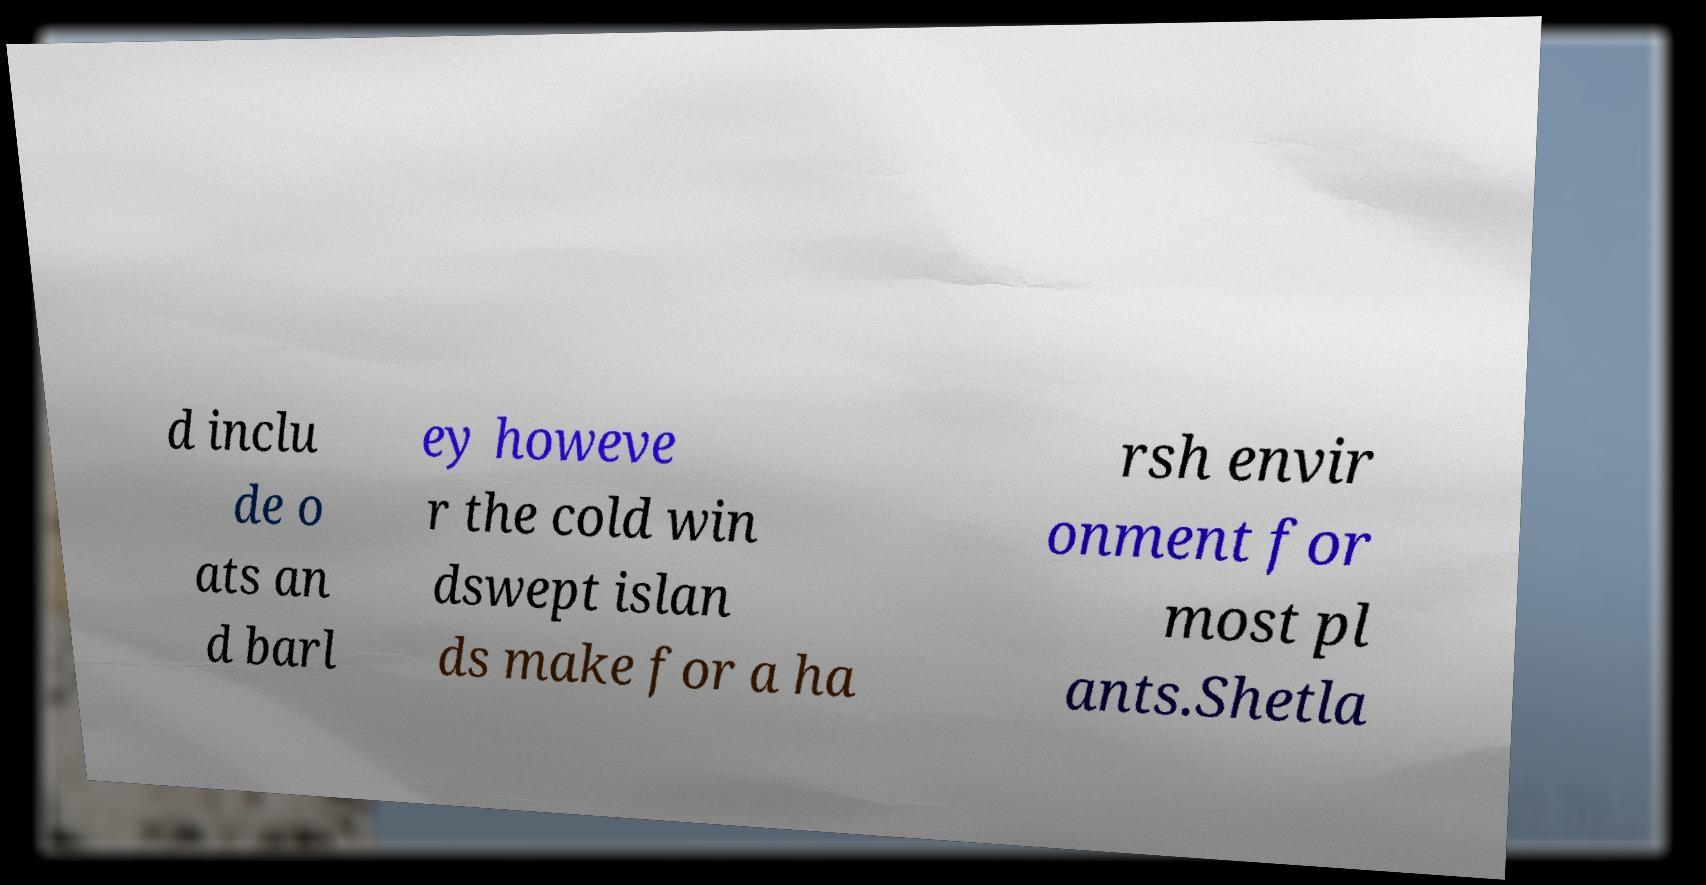Could you extract and type out the text from this image? d inclu de o ats an d barl ey howeve r the cold win dswept islan ds make for a ha rsh envir onment for most pl ants.Shetla 